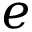Convert formula to latex. <formula><loc_0><loc_0><loc_500><loc_500>e</formula> 